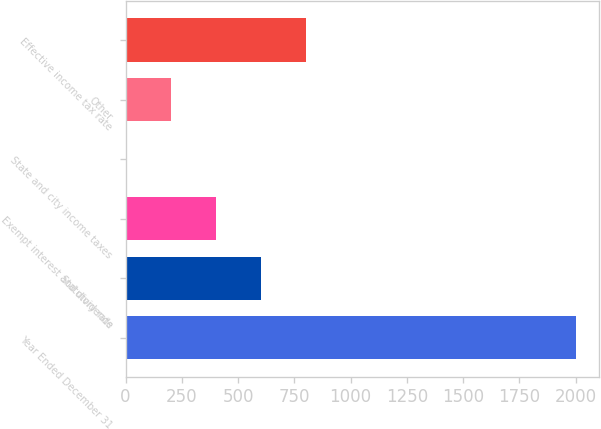Convert chart. <chart><loc_0><loc_0><loc_500><loc_500><bar_chart><fcel>Year Ended December 31<fcel>Statutory rate<fcel>Exempt interest and dividends<fcel>State and city income taxes<fcel>Other<fcel>Effective income tax rate<nl><fcel>2003<fcel>601.6<fcel>401.4<fcel>1<fcel>201.2<fcel>801.8<nl></chart> 